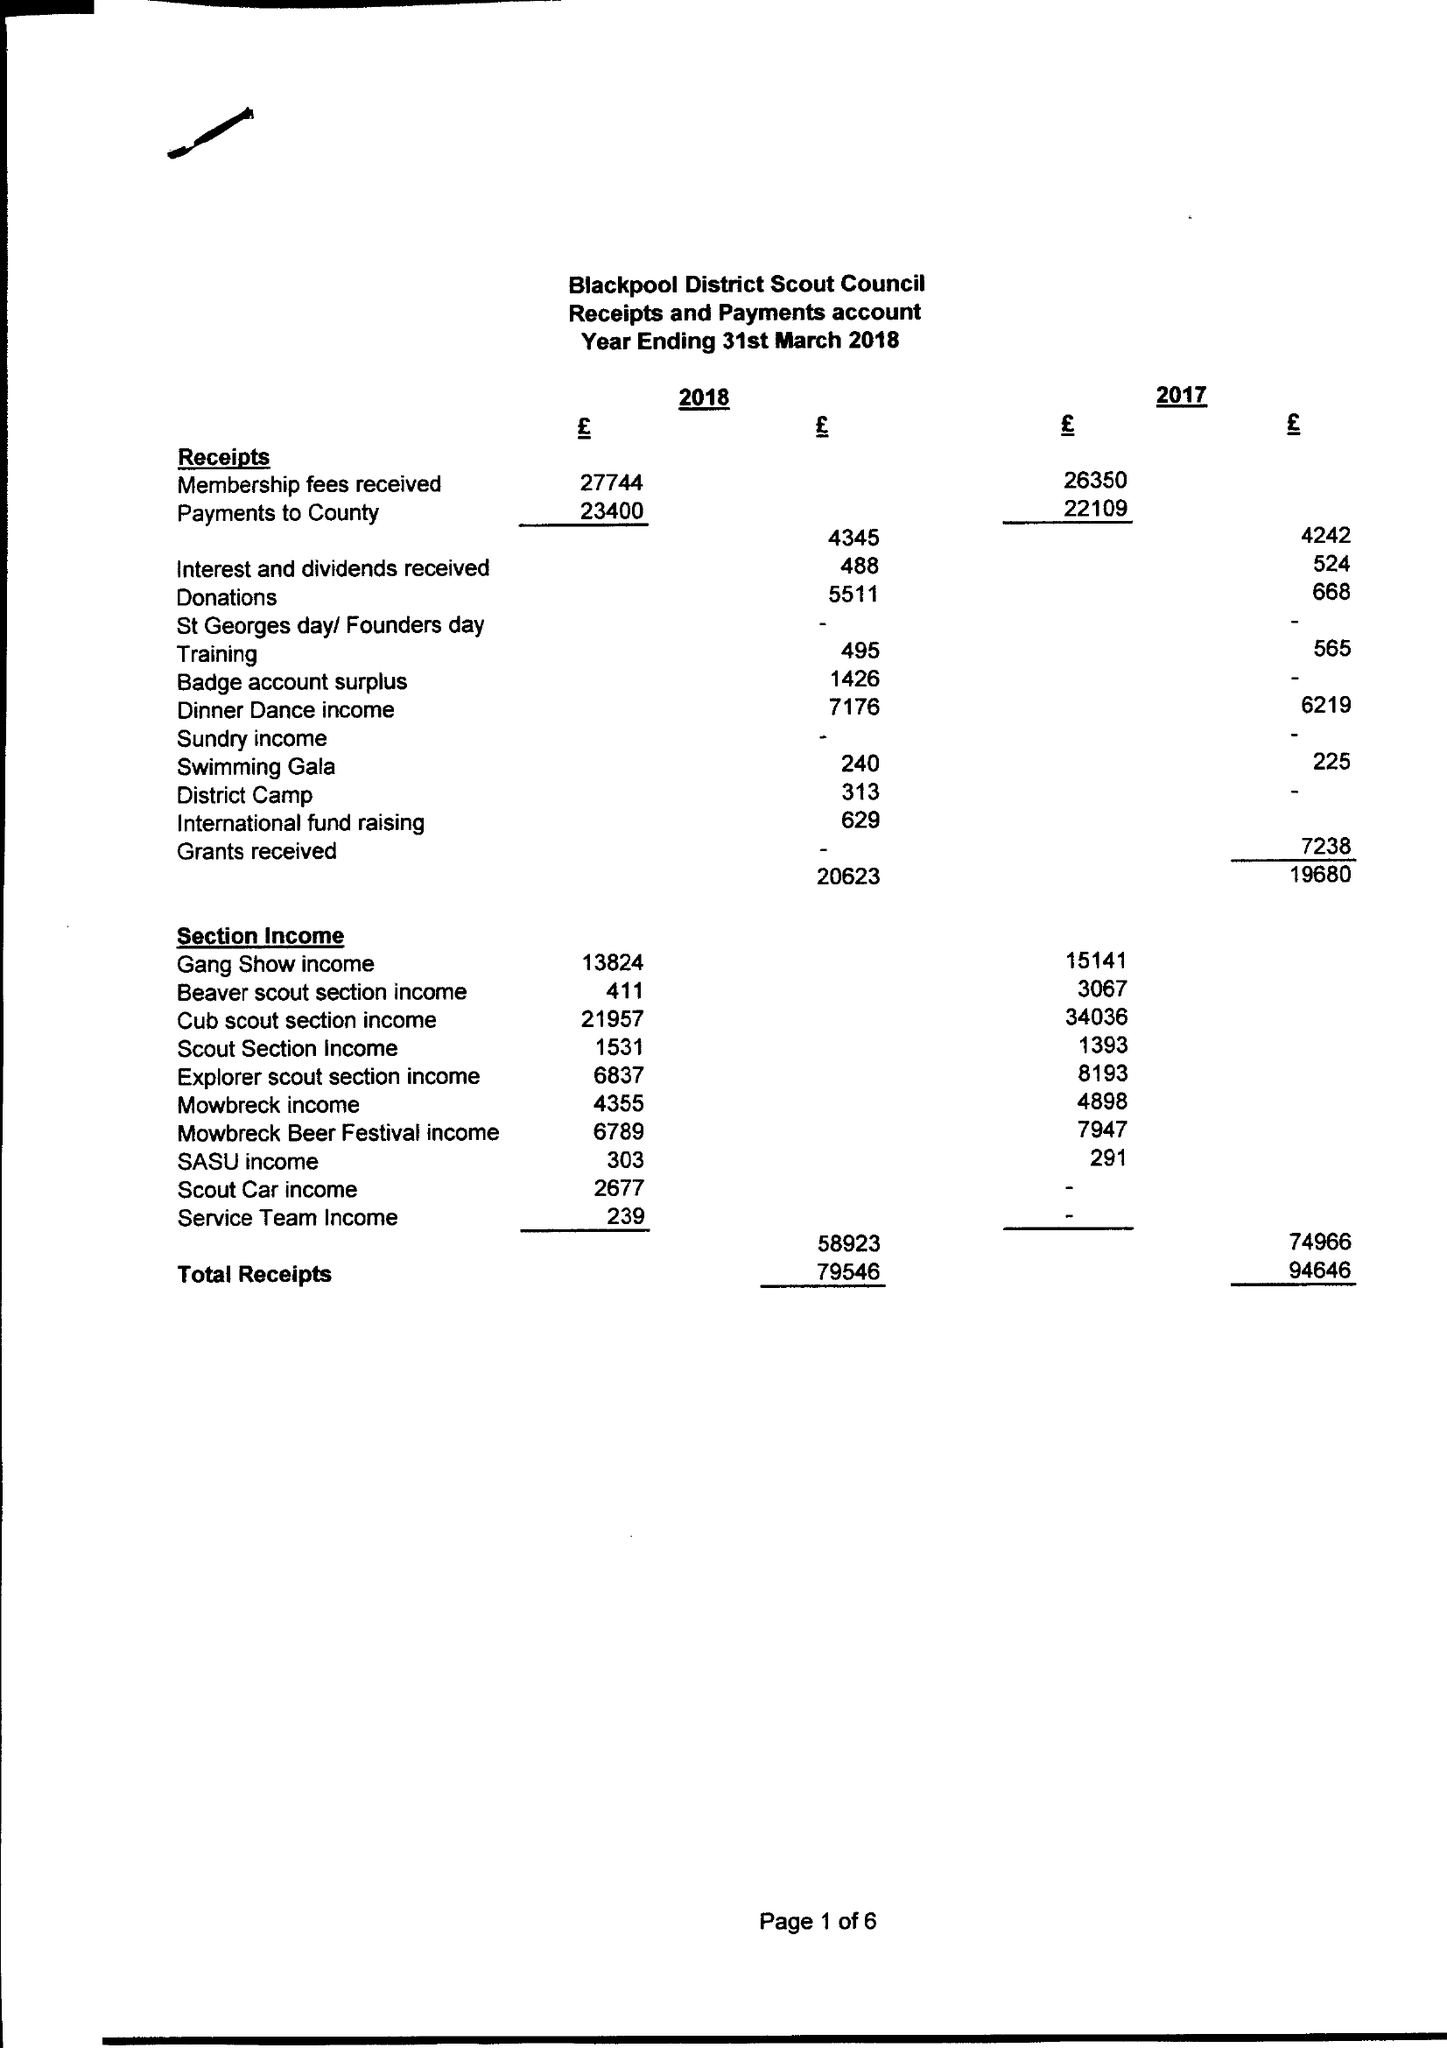What is the value for the income_annually_in_british_pounds?
Answer the question using a single word or phrase. 79546.00 